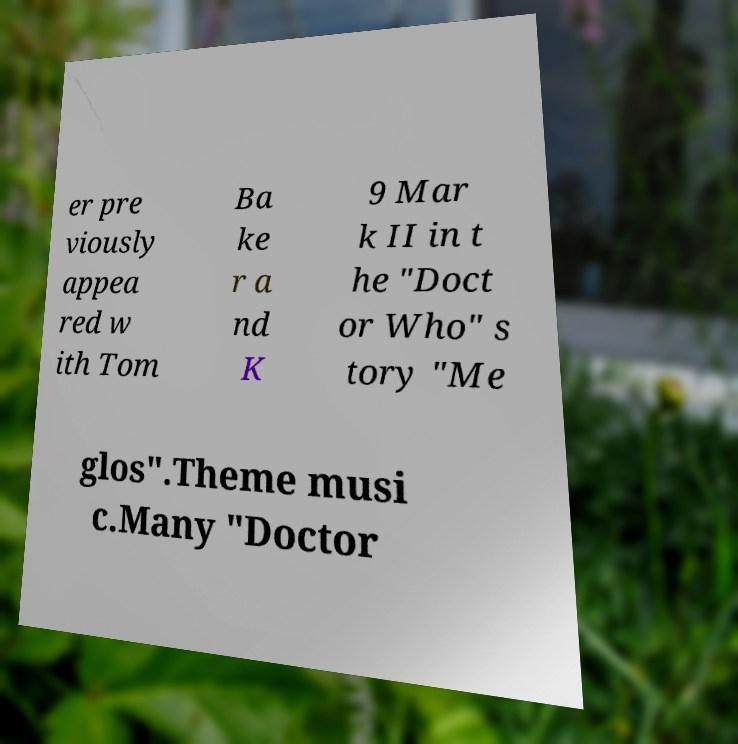There's text embedded in this image that I need extracted. Can you transcribe it verbatim? er pre viously appea red w ith Tom Ba ke r a nd K 9 Mar k II in t he "Doct or Who" s tory "Me glos".Theme musi c.Many "Doctor 